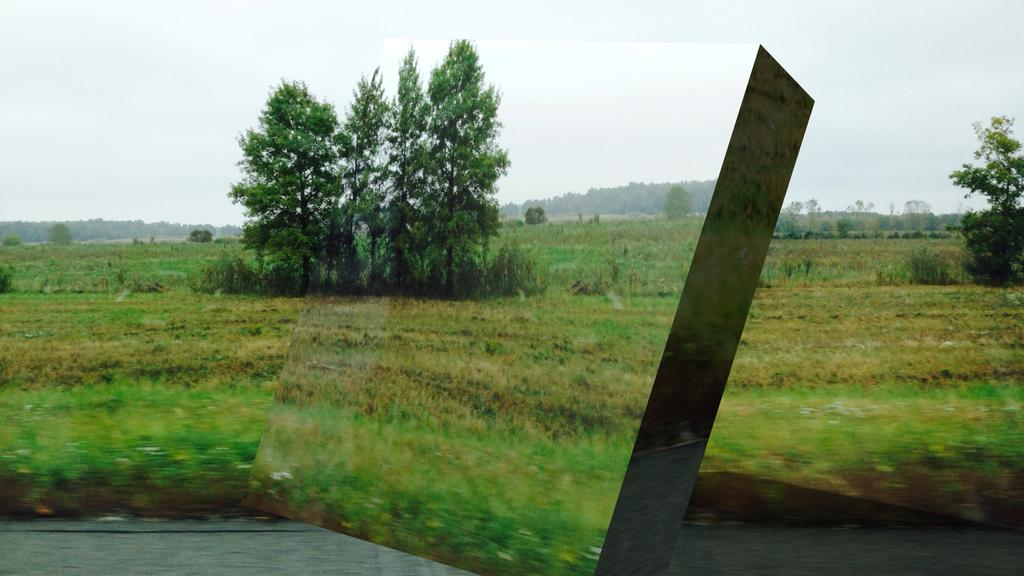What can be inferred about the image based on the provided fact? The image appears to be edited. What is located at the bottom of the image? There is a road at the bottom of the image. What type of natural elements are present in the middle of the image? There are many plants and trees in the middle of the image. What is visible at the top of the image? The sky is visible at the top of the image. How many rods can be seen in the image? There are no rods present in the image. What is the range of the plants and trees in the image? The range of the plants and trees cannot be determined from the image alone, as it only provides a snapshot of the scene. 